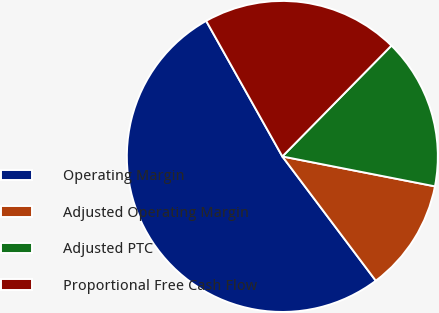<chart> <loc_0><loc_0><loc_500><loc_500><pie_chart><fcel>Operating Margin<fcel>Adjusted Operating Margin<fcel>Adjusted PTC<fcel>Proportional Free Cash Flow<nl><fcel>52.11%<fcel>11.66%<fcel>15.71%<fcel>20.52%<nl></chart> 